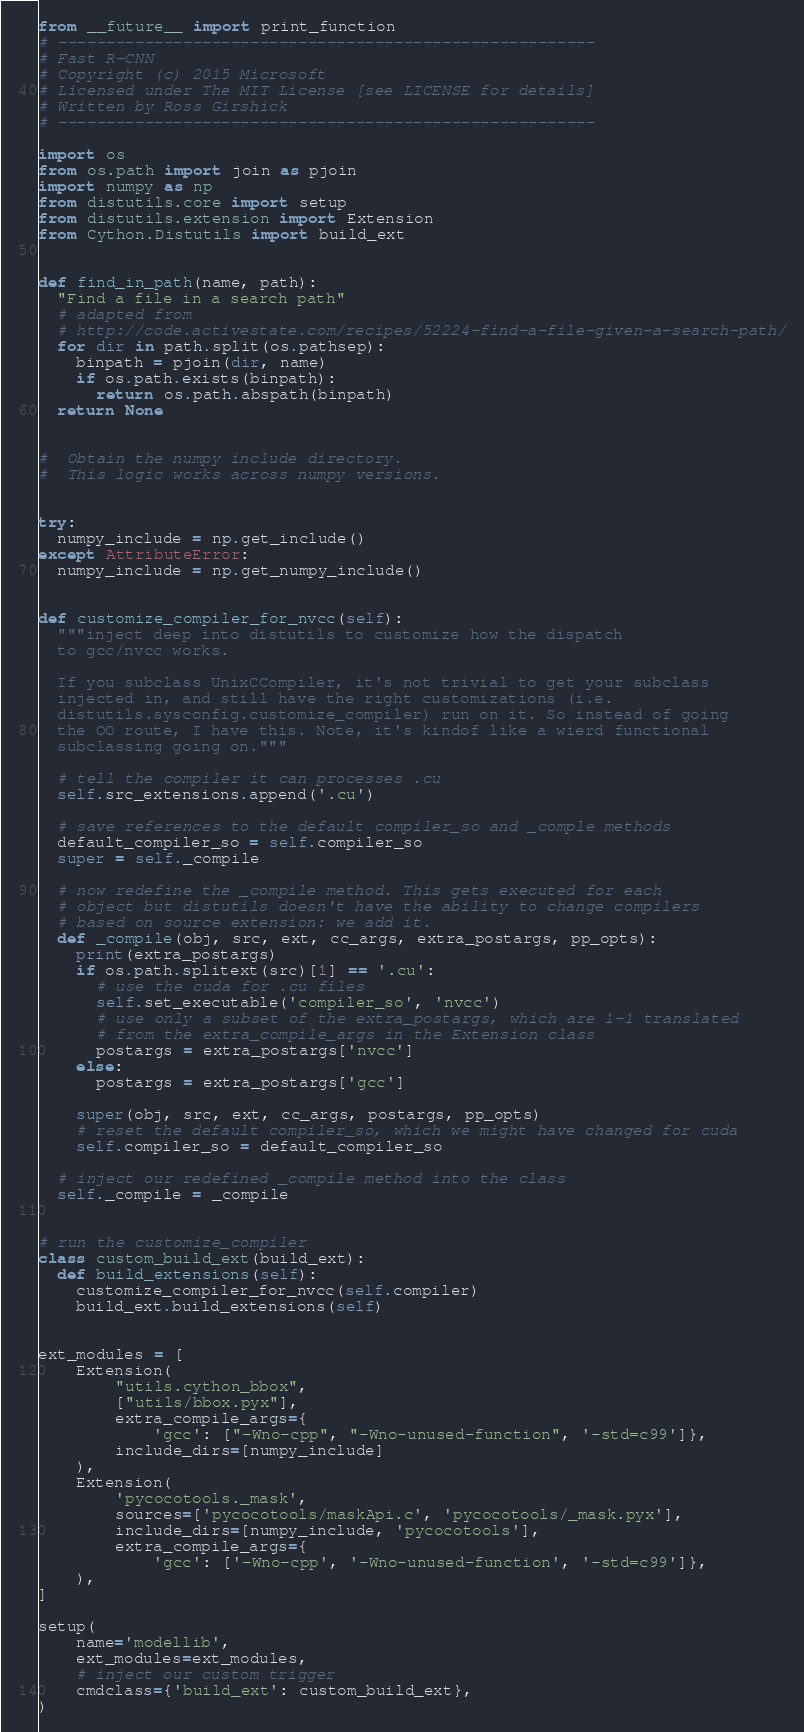Convert code to text. <code><loc_0><loc_0><loc_500><loc_500><_Python_>from __future__ import print_function
# --------------------------------------------------------
# Fast R-CNN
# Copyright (c) 2015 Microsoft
# Licensed under The MIT License [see LICENSE for details]
# Written by Ross Girshick
# --------------------------------------------------------

import os
from os.path import join as pjoin
import numpy as np
from distutils.core import setup
from distutils.extension import Extension
from Cython.Distutils import build_ext


def find_in_path(name, path):
  "Find a file in a search path"
  # adapted from
  # http://code.activestate.com/recipes/52224-find-a-file-given-a-search-path/
  for dir in path.split(os.pathsep):
    binpath = pjoin(dir, name)
    if os.path.exists(binpath):
      return os.path.abspath(binpath)
  return None


#  Obtain the numpy include directory.
#  This logic works across numpy versions.


try:
  numpy_include = np.get_include()
except AttributeError:
  numpy_include = np.get_numpy_include()


def customize_compiler_for_nvcc(self):
  """inject deep into distutils to customize how the dispatch
  to gcc/nvcc works.

  If you subclass UnixCCompiler, it's not trivial to get your subclass
  injected in, and still have the right customizations (i.e.
  distutils.sysconfig.customize_compiler) run on it. So instead of going
  the OO route, I have this. Note, it's kindof like a wierd functional
  subclassing going on."""

  # tell the compiler it can processes .cu
  self.src_extensions.append('.cu')

  # save references to the default compiler_so and _comple methods
  default_compiler_so = self.compiler_so
  super = self._compile

  # now redefine the _compile method. This gets executed for each
  # object but distutils doesn't have the ability to change compilers
  # based on source extension: we add it.
  def _compile(obj, src, ext, cc_args, extra_postargs, pp_opts):
    print(extra_postargs)
    if os.path.splitext(src)[1] == '.cu':
      # use the cuda for .cu files
      self.set_executable('compiler_so', 'nvcc')
      # use only a subset of the extra_postargs, which are 1-1 translated
      # from the extra_compile_args in the Extension class
      postargs = extra_postargs['nvcc']
    else:
      postargs = extra_postargs['gcc']

    super(obj, src, ext, cc_args, postargs, pp_opts)
    # reset the default compiler_so, which we might have changed for cuda
    self.compiler_so = default_compiler_so

  # inject our redefined _compile method into the class
  self._compile = _compile


# run the customize_compiler
class custom_build_ext(build_ext):
  def build_extensions(self):
    customize_compiler_for_nvcc(self.compiler)
    build_ext.build_extensions(self)


ext_modules = [
    Extension(
        "utils.cython_bbox",
        ["utils/bbox.pyx"],
        extra_compile_args={
            'gcc': ["-Wno-cpp", "-Wno-unused-function", '-std=c99']},
        include_dirs=[numpy_include]
    ),
    Extension(
        'pycocotools._mask',
        sources=['pycocotools/maskApi.c', 'pycocotools/_mask.pyx'],
        include_dirs=[numpy_include, 'pycocotools'],
        extra_compile_args={
            'gcc': ['-Wno-cpp', '-Wno-unused-function', '-std=c99']},
    ),
]

setup(
    name='modellib',
    ext_modules=ext_modules,
    # inject our custom trigger
    cmdclass={'build_ext': custom_build_ext},
)
</code> 